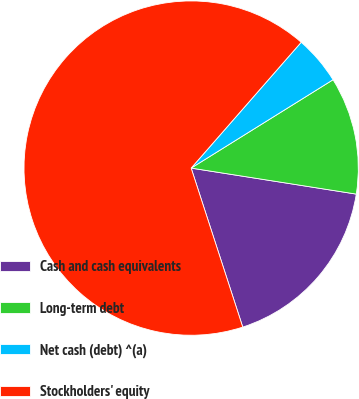Convert chart. <chart><loc_0><loc_0><loc_500><loc_500><pie_chart><fcel>Cash and cash equivalents<fcel>Long-term debt<fcel>Net cash (debt) ^(a)<fcel>Stockholders' equity<nl><fcel>17.52%<fcel>11.35%<fcel>4.7%<fcel>66.43%<nl></chart> 